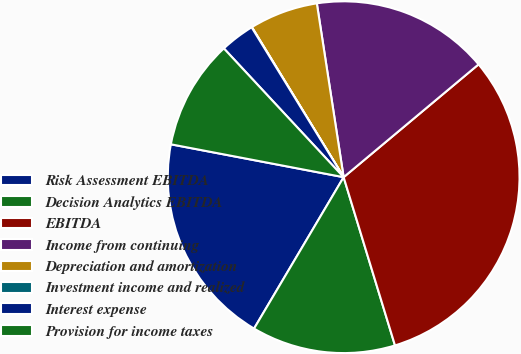Convert chart to OTSL. <chart><loc_0><loc_0><loc_500><loc_500><pie_chart><fcel>Risk Assessment EBITDA<fcel>Decision Analytics EBITDA<fcel>EBITDA<fcel>Income from continuing<fcel>Depreciation and amortization<fcel>Investment income and realized<fcel>Interest expense<fcel>Provision for income taxes<nl><fcel>19.49%<fcel>13.22%<fcel>31.37%<fcel>16.35%<fcel>6.3%<fcel>0.03%<fcel>3.16%<fcel>10.08%<nl></chart> 